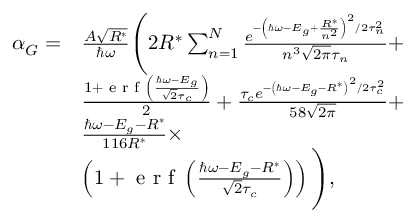<formula> <loc_0><loc_0><loc_500><loc_500>\begin{array} { r l } { \alpha _ { G } = } & { \frac { A \sqrt { R ^ { * } } } { \hbar { \omega } } \left ( 2 R ^ { * } \sum _ { n = 1 } ^ { N } \frac { e ^ { - \left ( \hbar { \omega } - E _ { g } + \frac { R ^ { * } } { n ^ { 2 } } \right ) ^ { 2 } / 2 \tau _ { n } ^ { 2 } } } { n ^ { 3 } \sqrt { 2 \pi } \tau _ { n } } + } \\ & { \frac { 1 + e r f \left ( \frac { \hbar { \omega } - E _ { g } } { \sqrt { 2 } \tau _ { c } } \right ) } { 2 } + \frac { \tau _ { c } e ^ { - \left ( \hbar { \omega } - E _ { g } - R ^ { * } \right ) ^ { 2 } / 2 \tau _ { c } ^ { 2 } } } { 5 8 \sqrt { 2 \pi } } + } \\ & { \frac { \hbar { \omega } - E _ { g } - R ^ { * } } { 1 1 6 R ^ { * } } \times } \\ & { \left ( 1 + e r f \left ( \frac { \hbar { \omega } - E _ { g } - R ^ { * } } { \sqrt { 2 } \tau _ { c } } \right ) \right ) \right ) , } \end{array}</formula> 